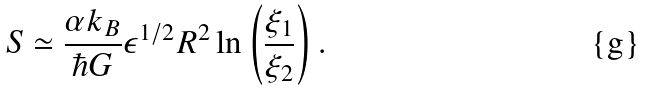Convert formula to latex. <formula><loc_0><loc_0><loc_500><loc_500>S \simeq \frac { \alpha k _ { B } } { \hbar { G } } \epsilon ^ { 1 / 2 } R ^ { 2 } \ln \left ( \frac { \xi _ { 1 } } { \xi _ { 2 } } \right ) .</formula> 